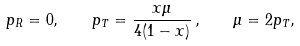Convert formula to latex. <formula><loc_0><loc_0><loc_500><loc_500>p _ { R } = 0 , \quad p _ { T } = \frac { x \mu } { 4 ( 1 - x ) } \, , \quad \mu = 2 p _ { T } ,</formula> 